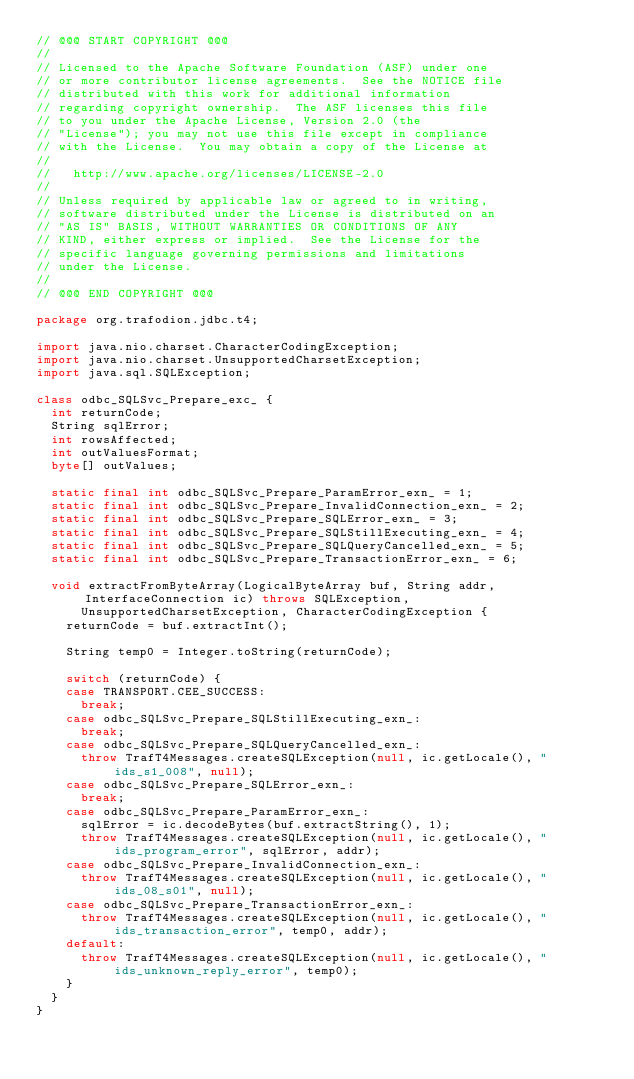Convert code to text. <code><loc_0><loc_0><loc_500><loc_500><_Java_>// @@@ START COPYRIGHT @@@
//
// Licensed to the Apache Software Foundation (ASF) under one
// or more contributor license agreements.  See the NOTICE file
// distributed with this work for additional information
// regarding copyright ownership.  The ASF licenses this file
// to you under the Apache License, Version 2.0 (the
// "License"); you may not use this file except in compliance
// with the License.  You may obtain a copy of the License at
//
//   http://www.apache.org/licenses/LICENSE-2.0
//
// Unless required by applicable law or agreed to in writing,
// software distributed under the License is distributed on an
// "AS IS" BASIS, WITHOUT WARRANTIES OR CONDITIONS OF ANY
// KIND, either express or implied.  See the License for the
// specific language governing permissions and limitations
// under the License.
//
// @@@ END COPYRIGHT @@@

package org.trafodion.jdbc.t4;

import java.nio.charset.CharacterCodingException;
import java.nio.charset.UnsupportedCharsetException;
import java.sql.SQLException;

class odbc_SQLSvc_Prepare_exc_ {
	int returnCode;
	String sqlError;
	int rowsAffected;
	int outValuesFormat;
	byte[] outValues;

	static final int odbc_SQLSvc_Prepare_ParamError_exn_ = 1;
	static final int odbc_SQLSvc_Prepare_InvalidConnection_exn_ = 2;
	static final int odbc_SQLSvc_Prepare_SQLError_exn_ = 3;
	static final int odbc_SQLSvc_Prepare_SQLStillExecuting_exn_ = 4;
	static final int odbc_SQLSvc_Prepare_SQLQueryCancelled_exn_ = 5;
	static final int odbc_SQLSvc_Prepare_TransactionError_exn_ = 6;

	void extractFromByteArray(LogicalByteArray buf, String addr, InterfaceConnection ic) throws SQLException,
			UnsupportedCharsetException, CharacterCodingException {
		returnCode = buf.extractInt();

		String temp0 = Integer.toString(returnCode);

		switch (returnCode) {
		case TRANSPORT.CEE_SUCCESS:
			break;
		case odbc_SQLSvc_Prepare_SQLStillExecuting_exn_:
			break;
		case odbc_SQLSvc_Prepare_SQLQueryCancelled_exn_:
			throw TrafT4Messages.createSQLException(null, ic.getLocale(), "ids_s1_008", null);
		case odbc_SQLSvc_Prepare_SQLError_exn_:
			break;
		case odbc_SQLSvc_Prepare_ParamError_exn_:
			sqlError = ic.decodeBytes(buf.extractString(), 1);
			throw TrafT4Messages.createSQLException(null, ic.getLocale(), "ids_program_error", sqlError, addr);
		case odbc_SQLSvc_Prepare_InvalidConnection_exn_:
			throw TrafT4Messages.createSQLException(null, ic.getLocale(), "ids_08_s01", null);
		case odbc_SQLSvc_Prepare_TransactionError_exn_:
			throw TrafT4Messages.createSQLException(null, ic.getLocale(), "ids_transaction_error", temp0, addr);
		default:
			throw TrafT4Messages.createSQLException(null, ic.getLocale(), "ids_unknown_reply_error", temp0);
		}
	}
}
</code> 